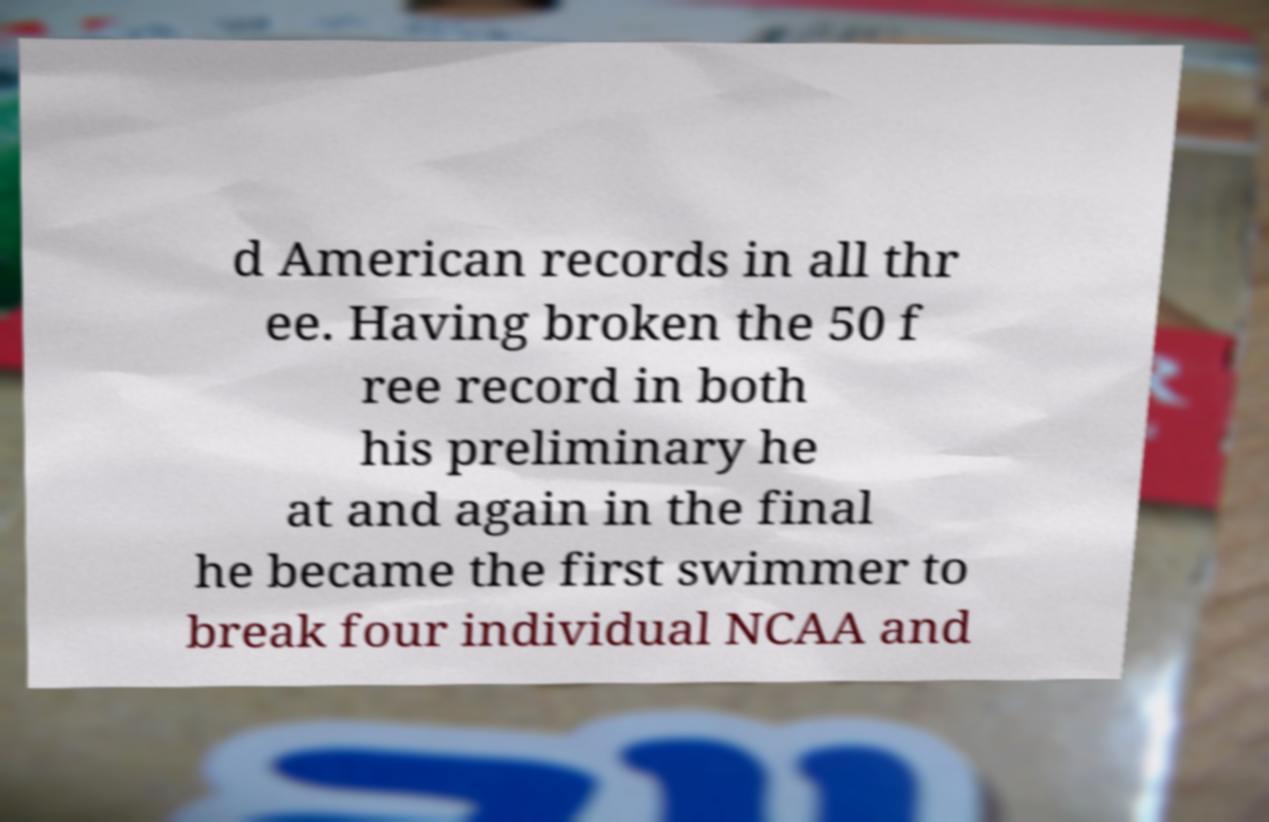There's text embedded in this image that I need extracted. Can you transcribe it verbatim? d American records in all thr ee. Having broken the 50 f ree record in both his preliminary he at and again in the final he became the first swimmer to break four individual NCAA and 